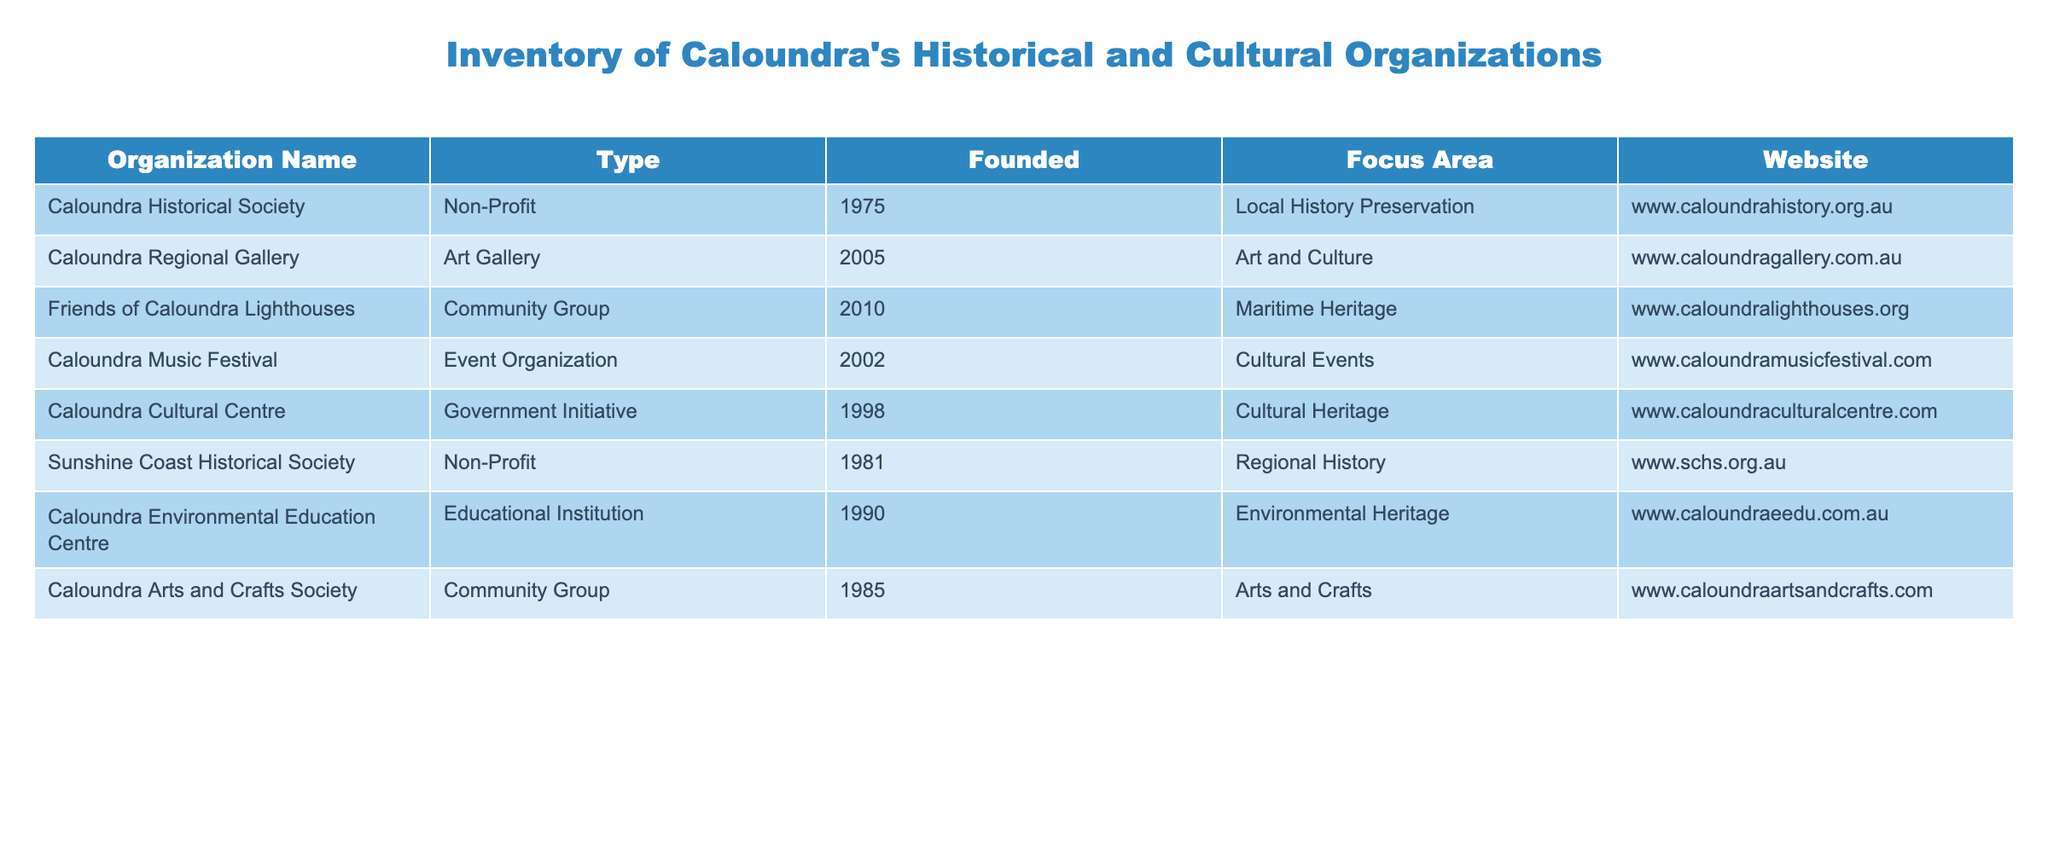What year was the Caloundra Historical Society founded? The Caloundra Historical Society is listed in the table under the "Founded" column, where it indicates that it was founded in 1975.
Answer: 1975 What is the focus area of the Caloundra Regional Gallery? In the table, the row for Caloundra Regional Gallery specifies that its focus area is "Art and Culture".
Answer: Art and Culture How many non-profit organizations are listed in the table? The table includes three organizations that are classified as non-profits: Caloundra Historical Society, Sunshine Coast Historical Society, and Caloundra Arts and Crafts Society. Counting these gives a total of 3.
Answer: 3 Are there any organizations founded after the year 2006? By examining the "Founded" column, we see that Friends of Caloundra Lighthouses (2010), and Caloundra Regional Gallery (2005) were established, meaning there is one organization after 2006, which is Friends of Caloundra Lighthouses.
Answer: Yes What is the average founding year of the organizations listed in the table? First, we add the years of founding: 1975 + 2005 + 2010 + 2002 + 1998 + 1981 + 1990 + 1985 = 1596. There are 8 organizations, so we divide: 1596 / 8 = 199.5, which means the average founding year is approximately 1999.
Answer: 1999 Which organization focuses on Environmental Heritage and what type is it? The table lists the Caloundra Environmental Education Centre as focusing on Environmental Heritage. Its type is categorized as an Educational Institution.
Answer: Caloundra Environmental Education Centre, Educational Institution Which organization has the website www.caloundramusicfestival.com? The website www.caloundramusicfestival.com is associated with the Caloundra Music Festival, as indicated in the table.
Answer: Caloundra Music Festival How many years passed between the founding of the Caloundra Cultural Centre and the Caloundra Music Festival? Caloundra Cultural Centre was founded in 1998 and Caloundra Music Festival in 2002. The difference is: 2002 - 1998 = 4 years.
Answer: 4 years What type of organization is the Friends of Caloundra Lighthouses? By reviewing the table, we find that the Friends of Caloundra Lighthouses is classified as a Community Group.
Answer: Community Group 